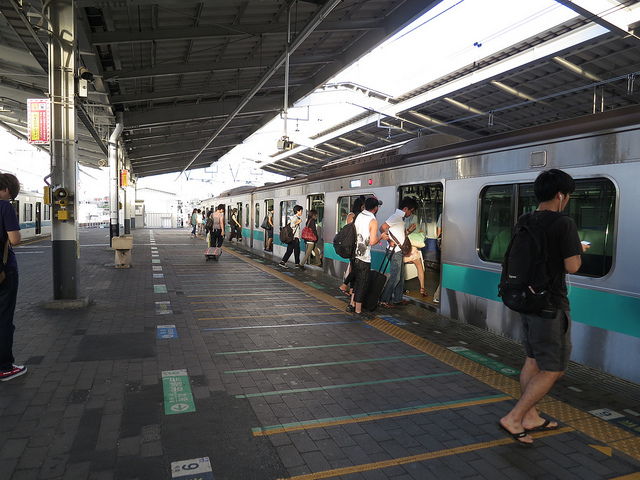Identify the text contained in this image. 6 